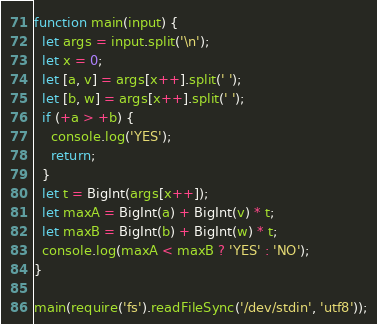Convert code to text. <code><loc_0><loc_0><loc_500><loc_500><_JavaScript_>
function main(input) {
  let args = input.split('\n');
  let x = 0;
  let [a, v] = args[x++].split(' ');
  let [b, w] = args[x++].split(' ');
  if (+a > +b) {
    console.log('YES');
    return;
  }
  let t = BigInt(args[x++]);
  let maxA = BigInt(a) + BigInt(v) * t;
  let maxB = BigInt(b) + BigInt(w) * t;
  console.log(maxA < maxB ? 'YES' : 'NO');
}

main(require('fs').readFileSync('/dev/stdin', 'utf8'));</code> 